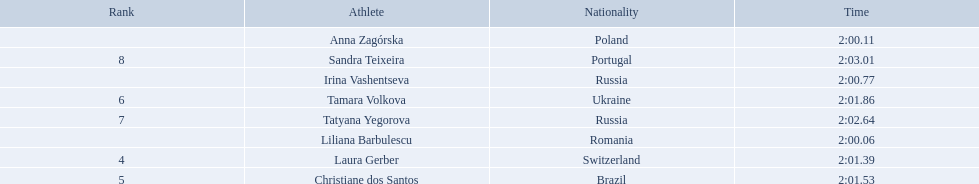What are the names of the competitors? Liliana Barbulescu, Anna Zagórska, Irina Vashentseva, Laura Gerber, Christiane dos Santos, Tamara Volkova, Tatyana Yegorova, Sandra Teixeira. Which finalist finished the fastest? Liliana Barbulescu. 